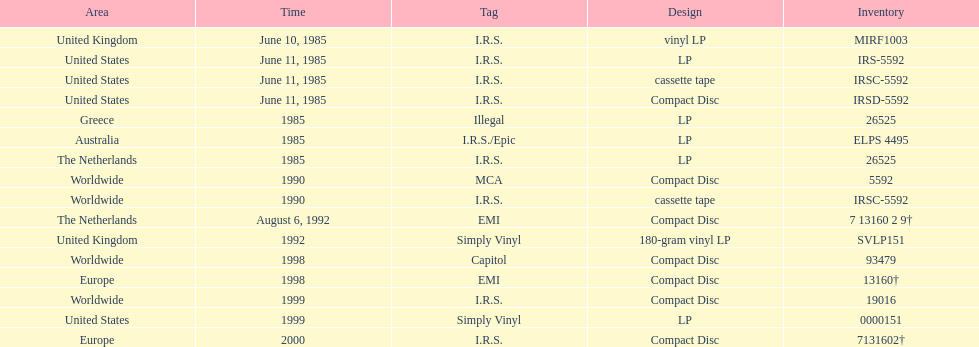What is the maximum successive quantity of releases in lp format? 3. 